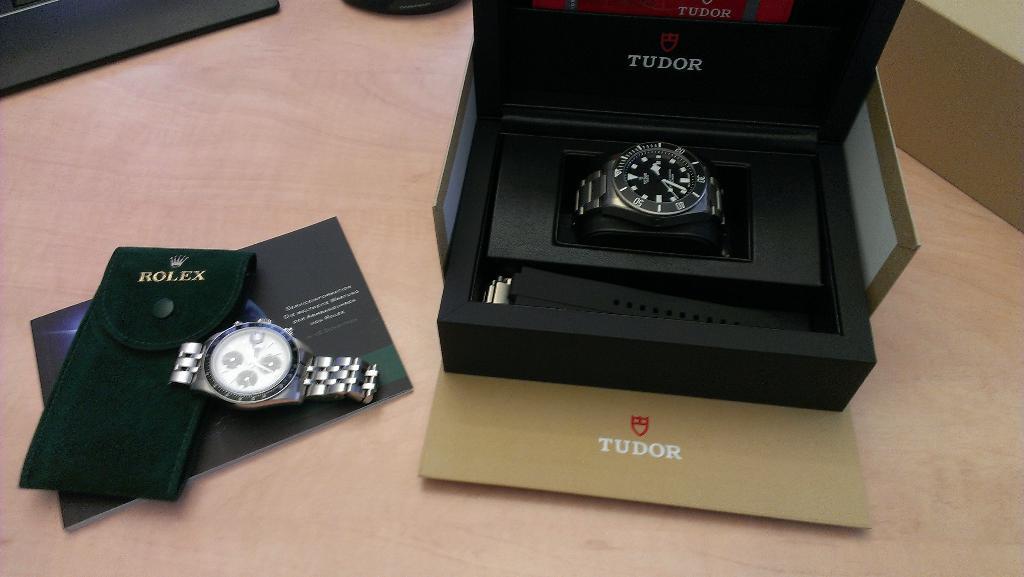What is the brand of watch on the left?
Make the answer very short. Rolex. What is the company name that is printed on the green watch bag?
Keep it short and to the point. Rolex. 